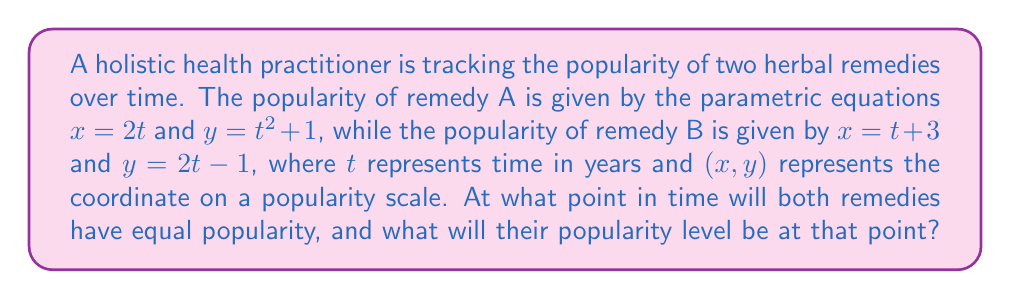Show me your answer to this math problem. To solve this problem, we need to find the intersection point of the two parametric curves. This point will represent when both remedies have equal popularity.

1) First, let's set the x-coordinates equal to each other:
   $2t = t + 3$

2) Solve for t:
   $t = 3$

3) Now that we know the time $t$, we can substitute this value into either set of equations to find the x and y coordinates of the intersection point.

   For remedy A:
   $x = 2t = 2(3) = 6$
   $y = t^2 + 1 = 3^2 + 1 = 10$

   For remedy B:
   $x = t + 3 = 3 + 3 = 6$
   $y = 2t - 1 = 2(3) - 1 = 5$

4) We can verify that these give the same x-coordinate, but we need to check if the y-coordinates are equal:

   $t^2 + 1 = 2t - 1$
   $3^2 + 1 = 2(3) - 1$
   $10 = 5$

5) Since the y-coordinates are not equal, there is no intersection point where both remedies have equal popularity.

6) However, we can find when their x-coordinates (time) are equal, which occurs at $t = 3$ years, or $x = 6$.

7) At this time, remedy A will have a popularity of $y = 10$, while remedy B will have a popularity of $y = 5$.
Answer: Both remedies will have the same time coordinate (x = 6) after 3 years, but they will not have equal popularity. At this time, remedy A will have a popularity of 10, while remedy B will have a popularity of 5 on the given scale. 